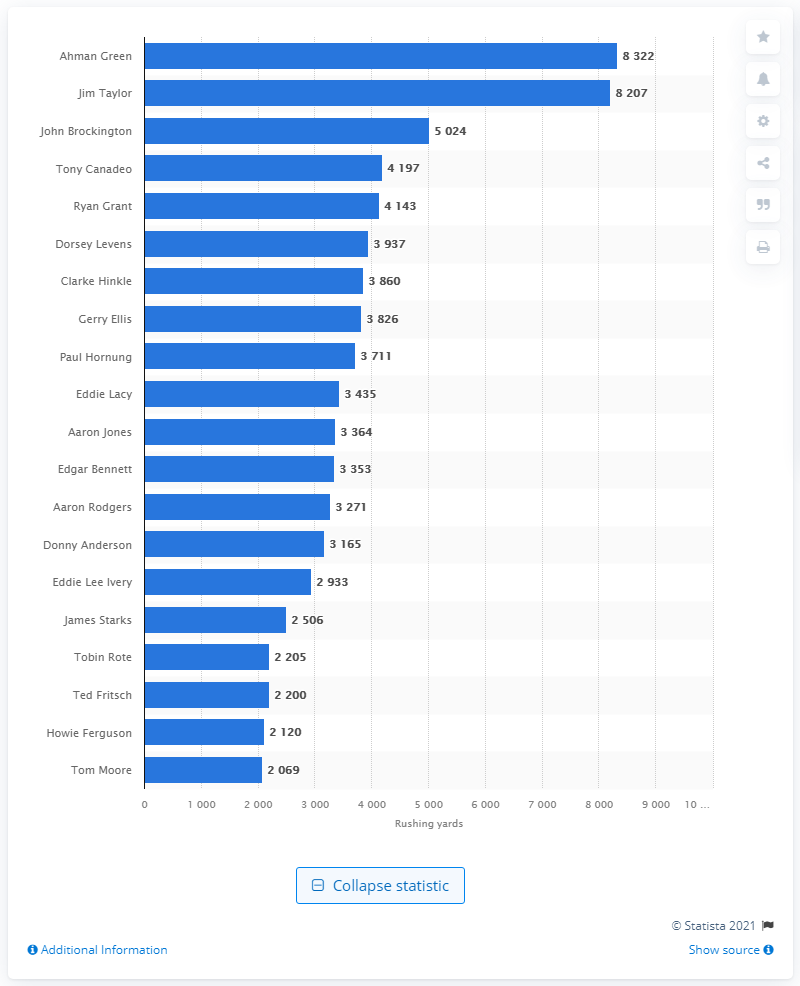Point out several critical features in this image. Ahman Green is the career rushing leader of the Green Bay Packers. 